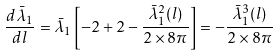Convert formula to latex. <formula><loc_0><loc_0><loc_500><loc_500>\frac { d \bar { \lambda } _ { 1 } } { d l } = \bar { \lambda } _ { 1 } \left [ - 2 + 2 - \frac { \bar { \lambda } _ { 1 } ^ { 2 } ( l ) } { 2 \times 8 \pi } \right ] = - \frac { \bar { \lambda } _ { 1 } ^ { 3 } ( l ) } { 2 \times 8 \pi }</formula> 